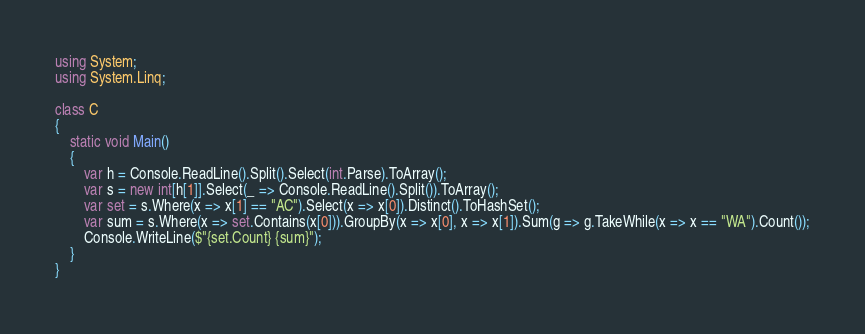Convert code to text. <code><loc_0><loc_0><loc_500><loc_500><_C#_>using System;
using System.Linq;

class C
{
	static void Main()
	{
		var h = Console.ReadLine().Split().Select(int.Parse).ToArray();
		var s = new int[h[1]].Select(_ => Console.ReadLine().Split()).ToArray();
		var set = s.Where(x => x[1] == "AC").Select(x => x[0]).Distinct().ToHashSet();
		var sum = s.Where(x => set.Contains(x[0])).GroupBy(x => x[0], x => x[1]).Sum(g => g.TakeWhile(x => x == "WA").Count());
		Console.WriteLine($"{set.Count} {sum}");
	}
}
</code> 